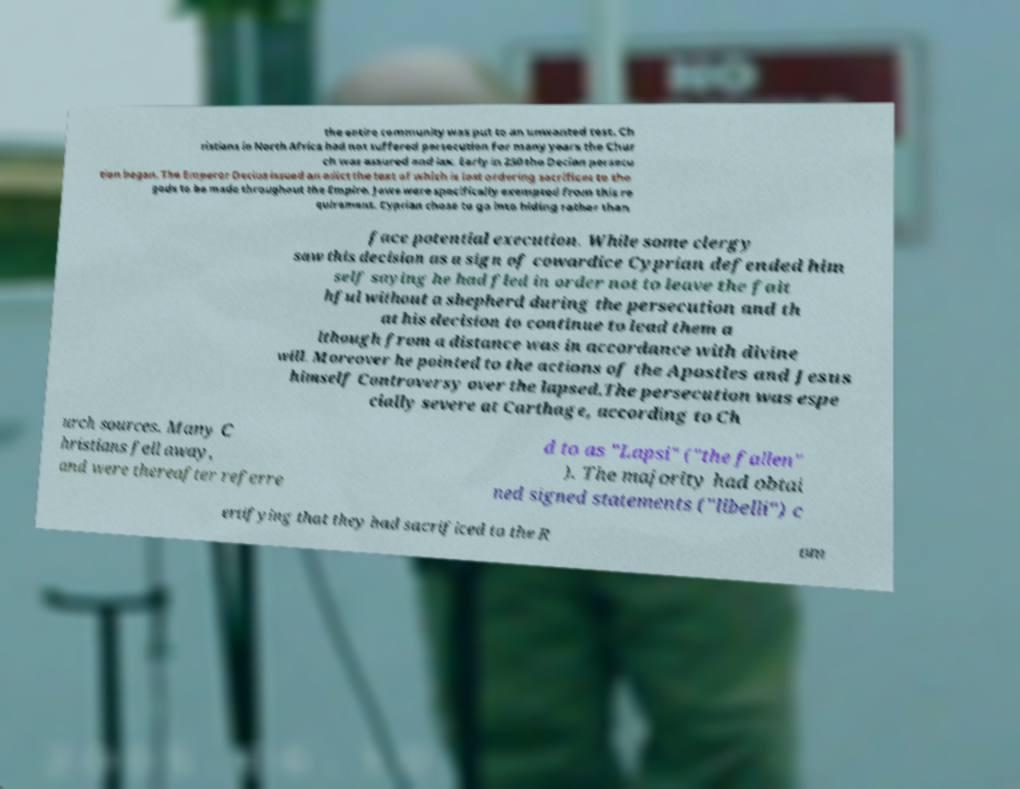Please identify and transcribe the text found in this image. the entire community was put to an unwanted test. Ch ristians in North Africa had not suffered persecution for many years the Chur ch was assured and lax. Early in 250 the Decian persecu tion began. The Emperor Decius issued an edict the text of which is lost ordering sacrifices to the gods to be made throughout the Empire. Jews were specifically exempted from this re quirement. Cyprian chose to go into hiding rather than face potential execution. While some clergy saw this decision as a sign of cowardice Cyprian defended him self saying he had fled in order not to leave the fait hful without a shepherd during the persecution and th at his decision to continue to lead them a lthough from a distance was in accordance with divine will. Moreover he pointed to the actions of the Apostles and Jesus himself Controversy over the lapsed.The persecution was espe cially severe at Carthage, according to Ch urch sources. Many C hristians fell away, and were thereafter referre d to as "Lapsi" ("the fallen" ). The majority had obtai ned signed statements ("libelli") c ertifying that they had sacrificed to the R om 